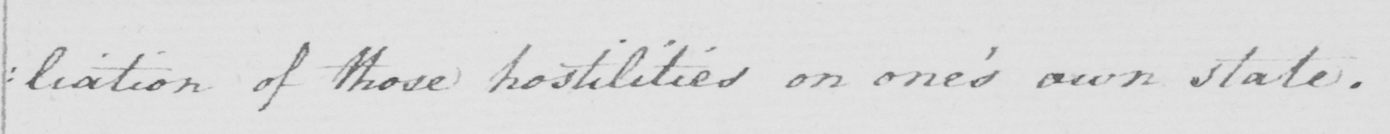Transcribe the text shown in this historical manuscript line. : liation of those hostilities on one ' s own state . 